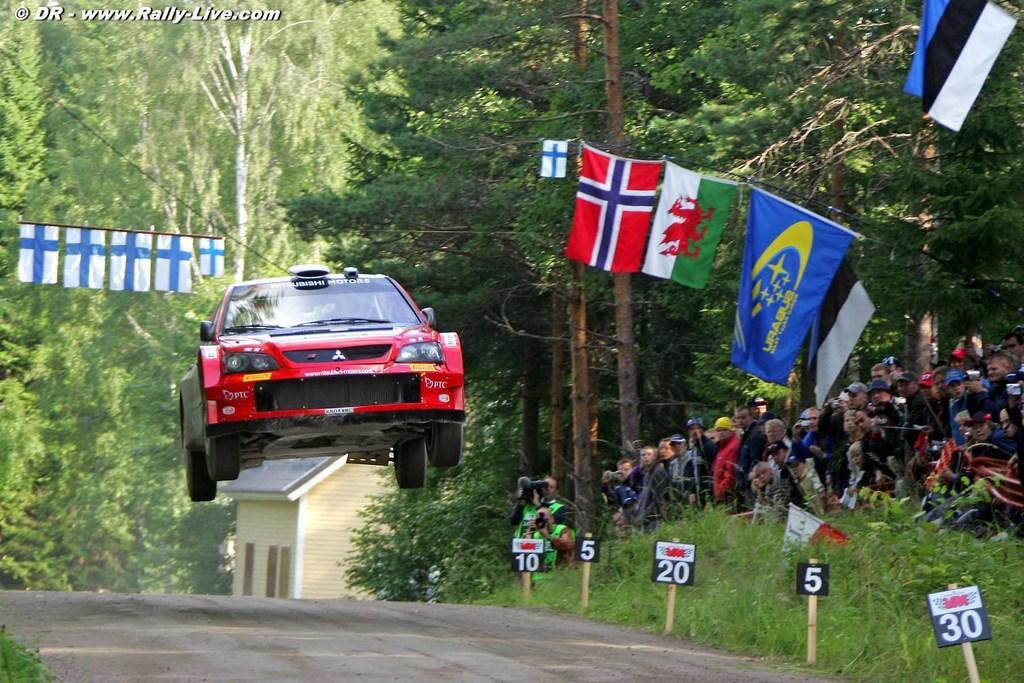How would you summarize this image in a sentence or two? In this picture we can see few flags and a car in the air, on the right side of the image we can see few boards, grass and group of people, in the background we can find few trees and a house, in the top left hand corner we can see some text and we can find few people holding cameras. 